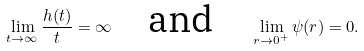<formula> <loc_0><loc_0><loc_500><loc_500>\lim _ { t \to \infty } \frac { h ( t ) } { t } = \infty \quad \text {and} \quad \lim _ { r \to 0 ^ { + } } \psi ( r ) = 0 .</formula> 